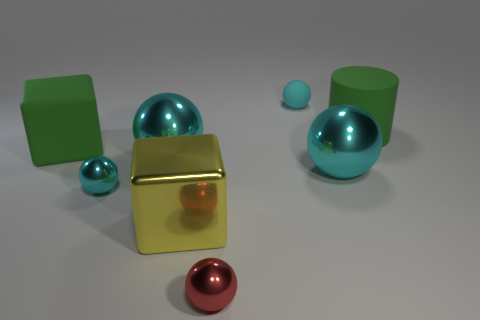Subtract all big shiny balls. How many balls are left? 3 Subtract all gray blocks. How many cyan balls are left? 4 Subtract all red spheres. How many spheres are left? 4 Add 1 purple matte blocks. How many objects exist? 9 Subtract 1 blocks. How many blocks are left? 1 Subtract all tiny spheres. Subtract all metallic balls. How many objects are left? 1 Add 6 large green rubber cylinders. How many large green rubber cylinders are left? 7 Add 7 big green blocks. How many big green blocks exist? 8 Subtract 0 cyan cubes. How many objects are left? 8 Subtract all blocks. How many objects are left? 6 